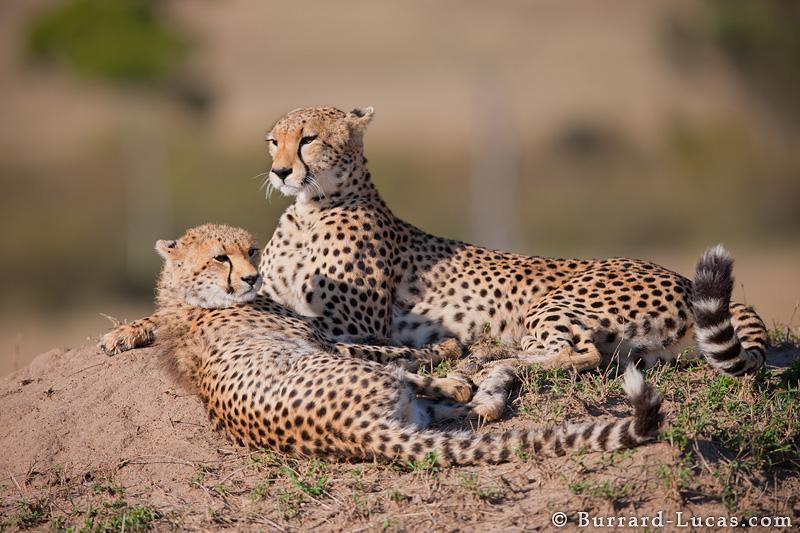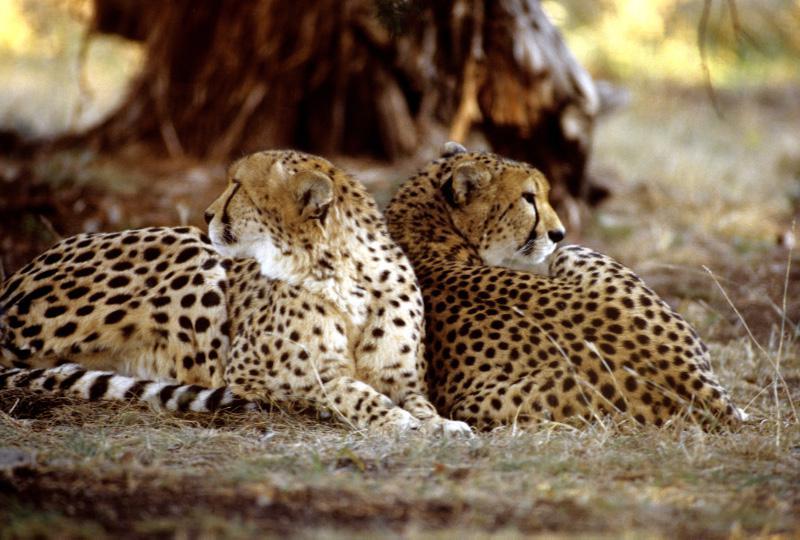The first image is the image on the left, the second image is the image on the right. Given the left and right images, does the statement "Each image contains exactly two cheetahs, and each image includes at least one reclining cheetah." hold true? Answer yes or no. Yes. The first image is the image on the left, the second image is the image on the right. Given the left and right images, does the statement "In one of the images there is a single animal standing in a field." hold true? Answer yes or no. No. 